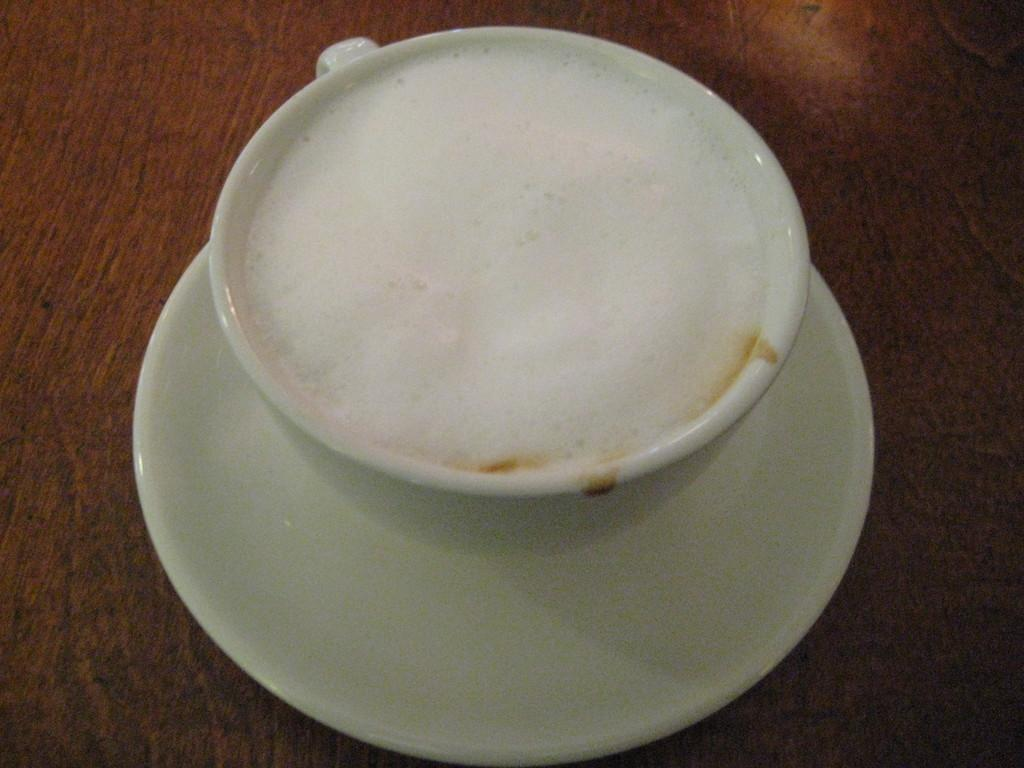What is in the image that can hold liquids? There is a cup in the image. What color is the cup? The cup is white. Is there anything accompanying the cup in the image? Yes, there is a saucer in the image. What color is the saucer? The saucer is white. What is inside the cup? There is a liquid in the cup. What color is the liquid? The liquid is white. On what surface is the saucer placed? The saucer is on a brown surface. What type of flower is growing out of the cup in the image? There is no flower growing out of the cup in the image; it contains a white liquid. 